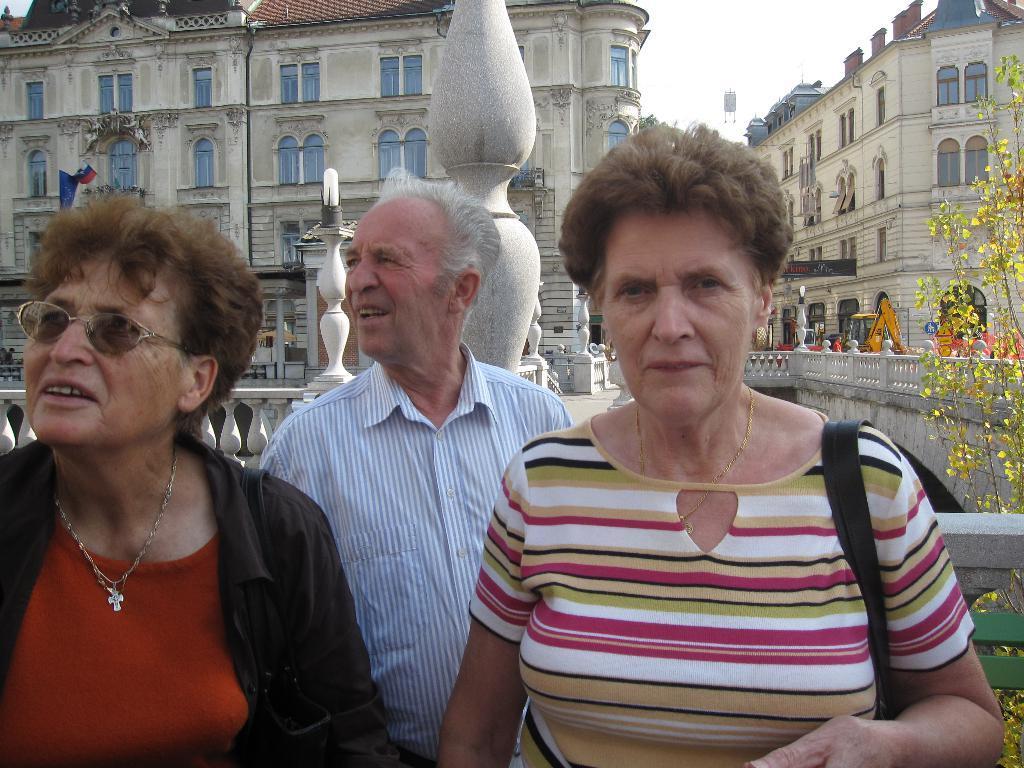In one or two sentences, can you explain what this image depicts? In this image I can see three persons standing. In the background I can see few plants in green color and I can also see few buildings and the sky is in white color. 